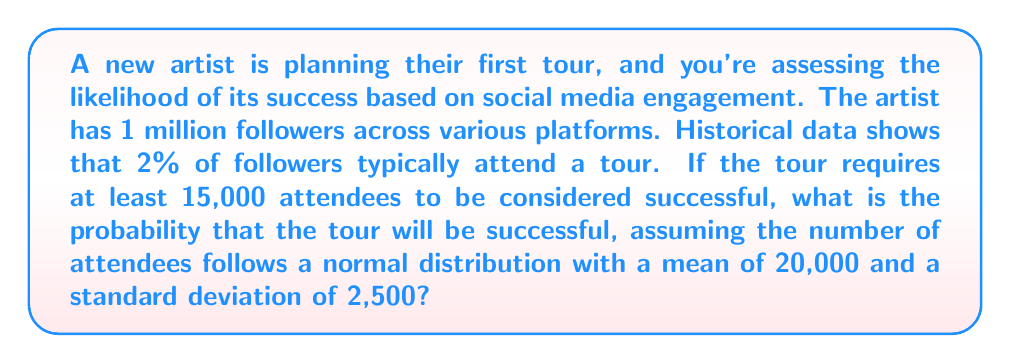Can you solve this math problem? Let's approach this step-by-step:

1) First, we need to identify the relevant information:
   - The tour is considered successful if at least 15,000 people attend.
   - The number of attendees follows a normal distribution.
   - Mean (μ) = 20,000
   - Standard deviation (σ) = 2,500

2) We want to find P(X ≥ 15,000), where X is the number of attendees.

3) To solve this, we need to calculate the z-score for 15,000:

   $$z = \frac{X - μ}{σ} = \frac{15,000 - 20,000}{2,500} = -2$$

4) Now, we need to find the probability that z is greater than or equal to -2.

5) Using a standard normal distribution table or calculator, we can find that:
   P(Z ≥ -2) = 1 - P(Z < -2) = 1 - 0.0228 = 0.9772

6) Therefore, the probability that the tour will be successful is approximately 0.9772 or 97.72%.

Note: The given information about 2% of followers typically attending wasn't necessary for this calculation, as we were provided with the mean and standard deviation of the attendance distribution directly.
Answer: 0.9772 